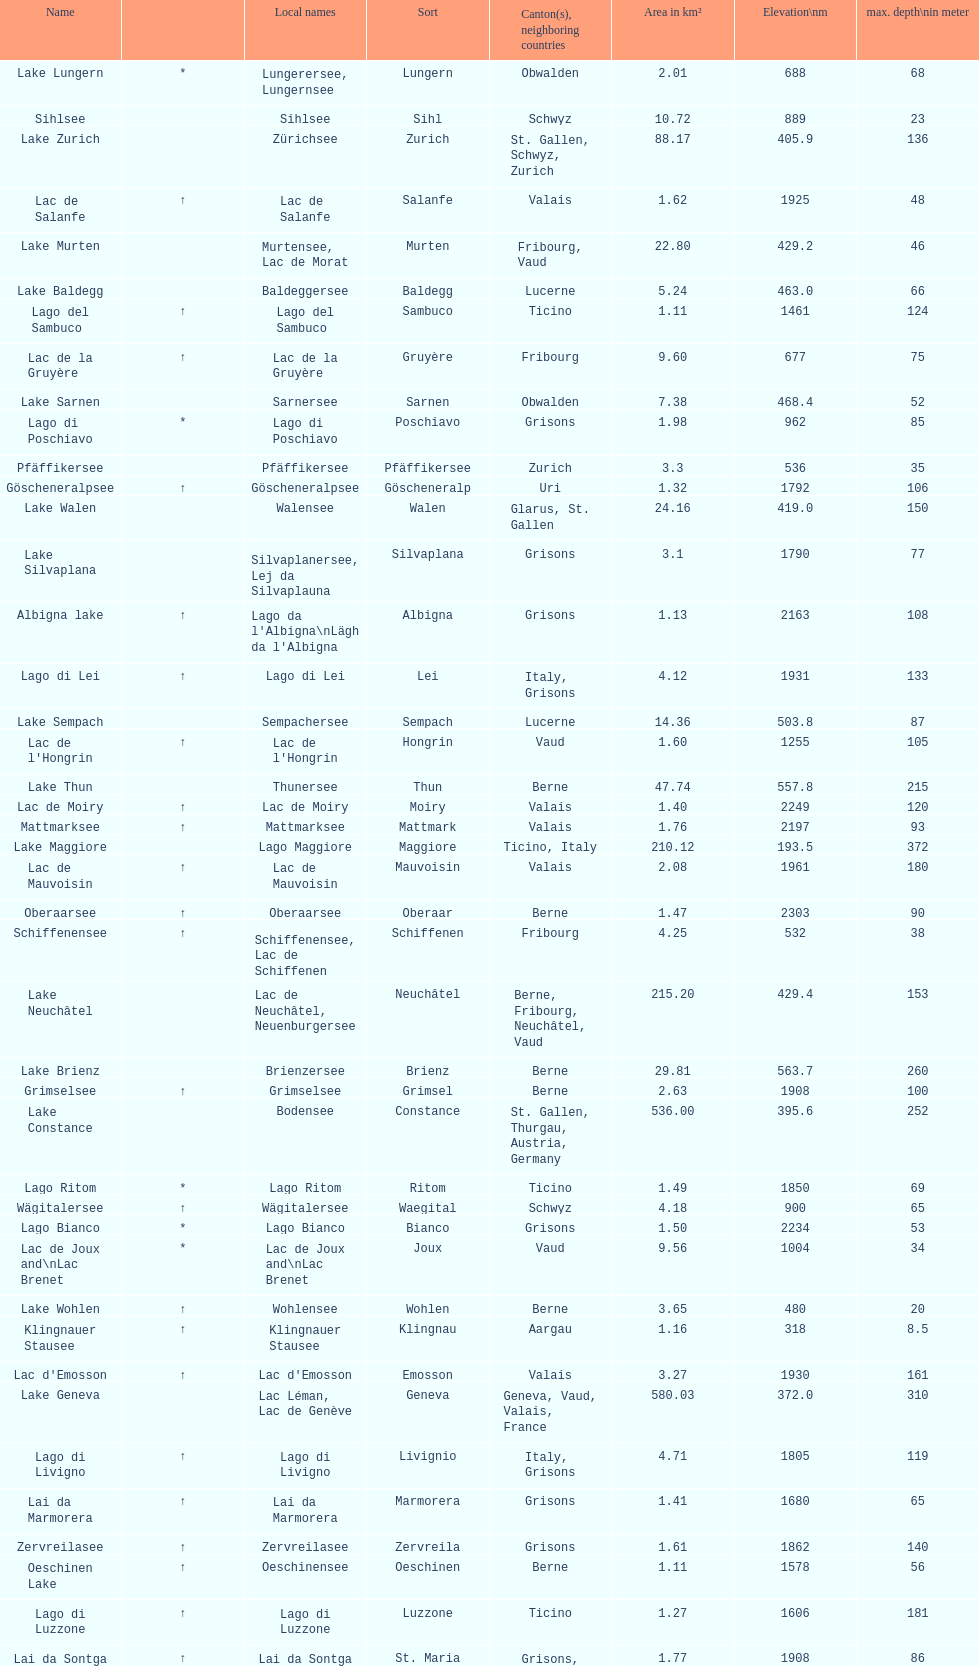Which lake is smaller in area km²? albigna lake or oeschinen lake? Oeschinen Lake. 